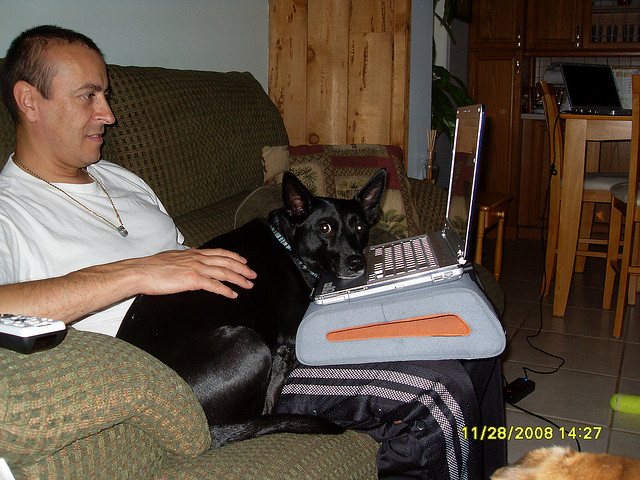Read and extract the text from this image. 11/28/2008 14:27 